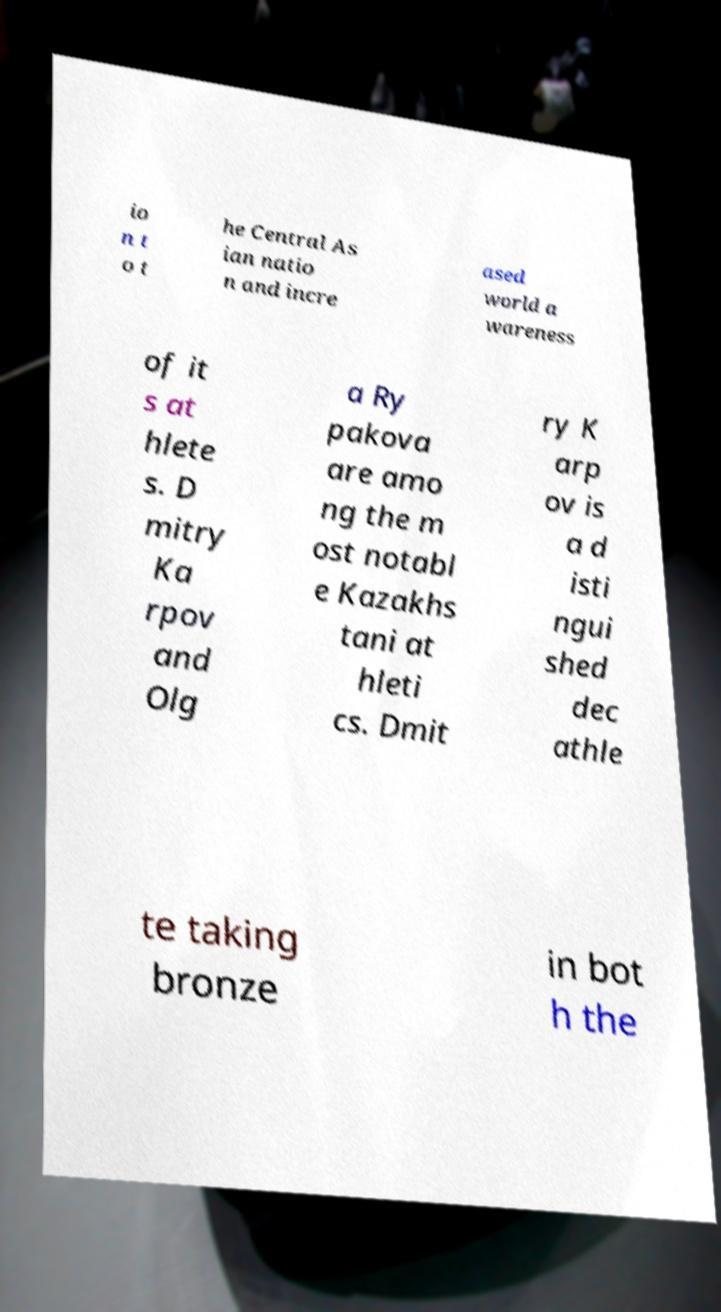There's text embedded in this image that I need extracted. Can you transcribe it verbatim? io n t o t he Central As ian natio n and incre ased world a wareness of it s at hlete s. D mitry Ka rpov and Olg a Ry pakova are amo ng the m ost notabl e Kazakhs tani at hleti cs. Dmit ry K arp ov is a d isti ngui shed dec athle te taking bronze in bot h the 